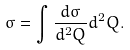<formula> <loc_0><loc_0><loc_500><loc_500>\sigma = \int \frac { d \sigma } { d ^ { 2 } Q } d ^ { 2 } Q .</formula> 